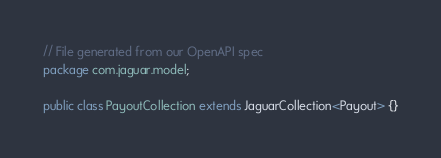Convert code to text. <code><loc_0><loc_0><loc_500><loc_500><_Java_>// File generated from our OpenAPI spec
package com.jaguar.model;

public class PayoutCollection extends JaguarCollection<Payout> {}
</code> 